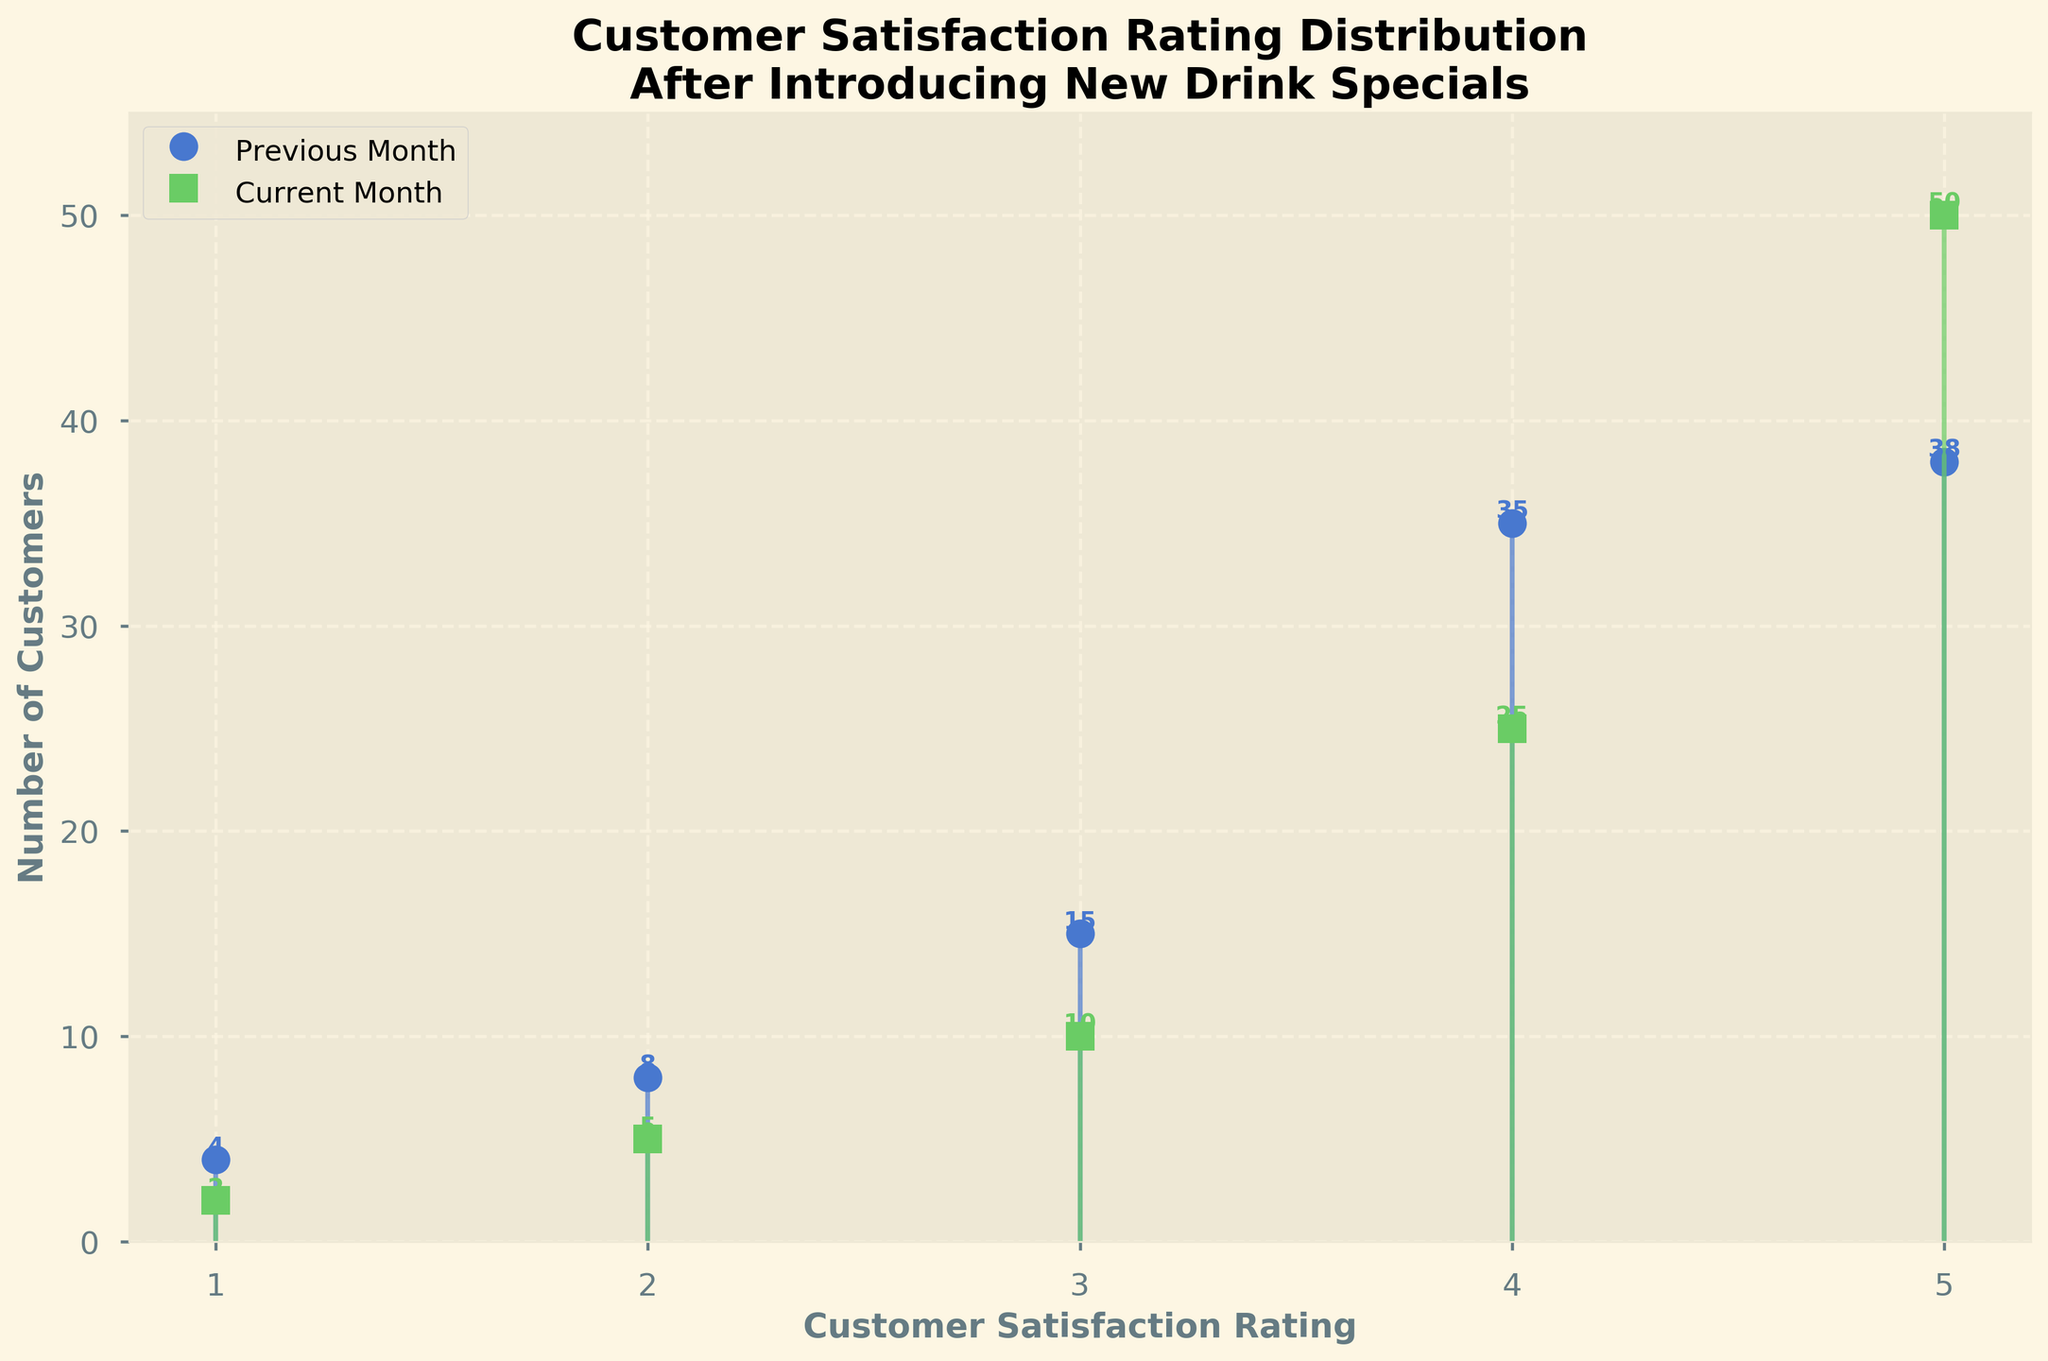What's the title of the figure? The title can be found at the top of the figure, usually indicating what the figure represents. In this case, it is "Customer Satisfaction Rating Distribution After Introducing New Drink Specials".
Answer: Customer Satisfaction Rating Distribution After Introducing New Drink Specials What are the labels for the X and Y axes? The X-axis label describes what is being measured on the horizontal axis, and the Y-axis label describes what is being measured on the vertical axis. The X-axis is labeled "Customer Satisfaction Rating", and the Y-axis is labeled "Number of Customers".
Answer: Customer Satisfaction Rating and Number of Customers How many customer satisfaction ratings are shown in the figure? By observing the X-axis ticks or points, we can count the number of ratings presented. There are ratings from 1 to 5.
Answer: 5 Which month had the highest number of customers giving a rating of 5? To find this, we look at the stem plot for the rating of 5 and compare the heights of the stems for the previous and current months. The current month has a taller stem.
Answer: Current Month What is the difference in the number of customers who gave a rating of 4 between the previous and current months? To determine this, we subtract the number of customers in the current month from the number in the previous month for the rating of 4. The numbers are 35 (previous) and 25 (current), so 35 - 25 = 10.
Answer: 10 What percentage increase in customers gave a rating of 5 between the previous and current months? To calculate the percentage increase, we use the formula [(new number - old number) / old number] * 100. For rating 5, the numbers are 50 (current) and 38 (previous), so [(50 - 38) / 38] * 100 ≈ 31.58%.
Answer: ≈ 31.58% Which rating showed the most significant improvement in customer numbers from the previous month to the current month? We need to compare the differences for each rating and identify the largest difference. Rating 5 increased by 12 (50 - 38), which is the most significant improvement.
Answer: Rating 5 For which rating did the number of customers decrease the most from the previous month to the current month? We look at the differences for each rating and find the largest decrease. Rating 4 decreased by 10 (35 - 25), which is the most significant decrease.
Answer: Rating 4 What's the total number of customers for the current month according to the figure? We sum up the numbers for each rating in the current month. The values are 2 + 5 + 10 + 25 + 50, so the total is 2 + 5 + 10 + 25 + 50 = 92.
Answer: 92 